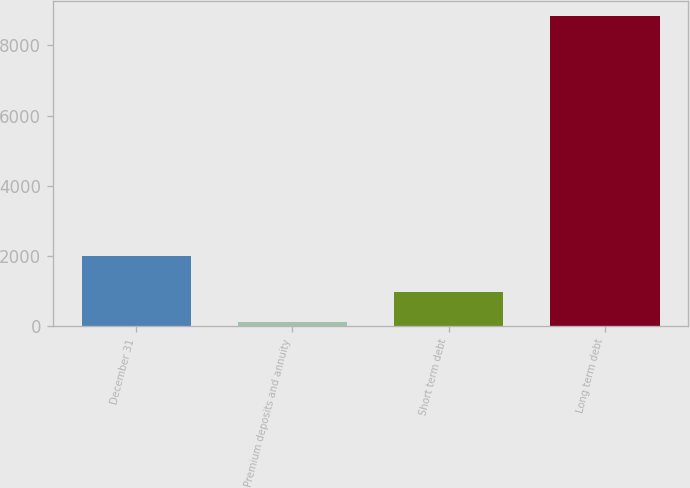<chart> <loc_0><loc_0><loc_500><loc_500><bar_chart><fcel>December 31<fcel>Premium deposits and annuity<fcel>Short term debt<fcel>Long term debt<nl><fcel>2010<fcel>104<fcel>976.6<fcel>8830<nl></chart> 